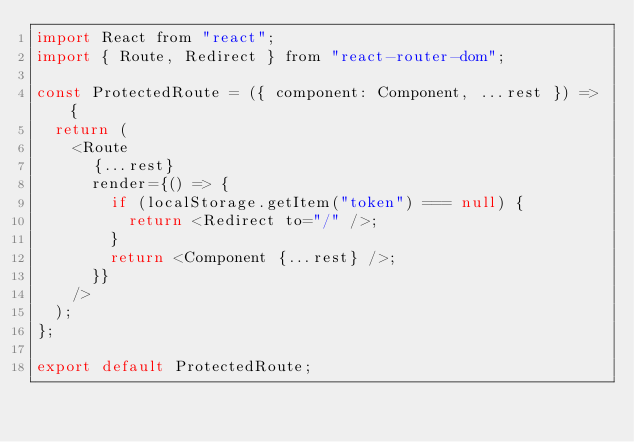<code> <loc_0><loc_0><loc_500><loc_500><_JavaScript_>import React from "react";
import { Route, Redirect } from "react-router-dom";

const ProtectedRoute = ({ component: Component, ...rest }) => {
  return (
    <Route
      {...rest}
      render={() => {
        if (localStorage.getItem("token") === null) {
          return <Redirect to="/" />;
        }
        return <Component {...rest} />;
      }}
    />
  );
};

export default ProtectedRoute;
</code> 